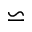Convert formula to latex. <formula><loc_0><loc_0><loc_500><loc_500>\backsimeq</formula> 